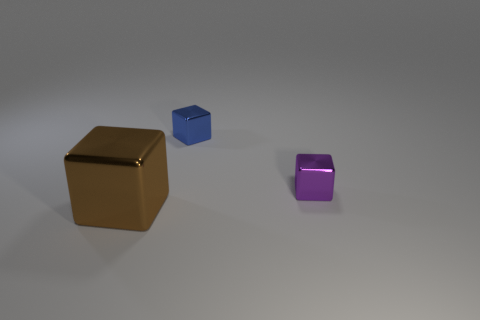Subtract all tiny cubes. How many cubes are left? 1 Add 3 small red rubber blocks. How many objects exist? 6 Subtract all purple cubes. How many cubes are left? 2 Subtract all large purple matte spheres. Subtract all cubes. How many objects are left? 0 Add 2 blocks. How many blocks are left? 5 Add 1 rubber spheres. How many rubber spheres exist? 1 Subtract 0 blue cylinders. How many objects are left? 3 Subtract all purple blocks. Subtract all cyan cylinders. How many blocks are left? 2 